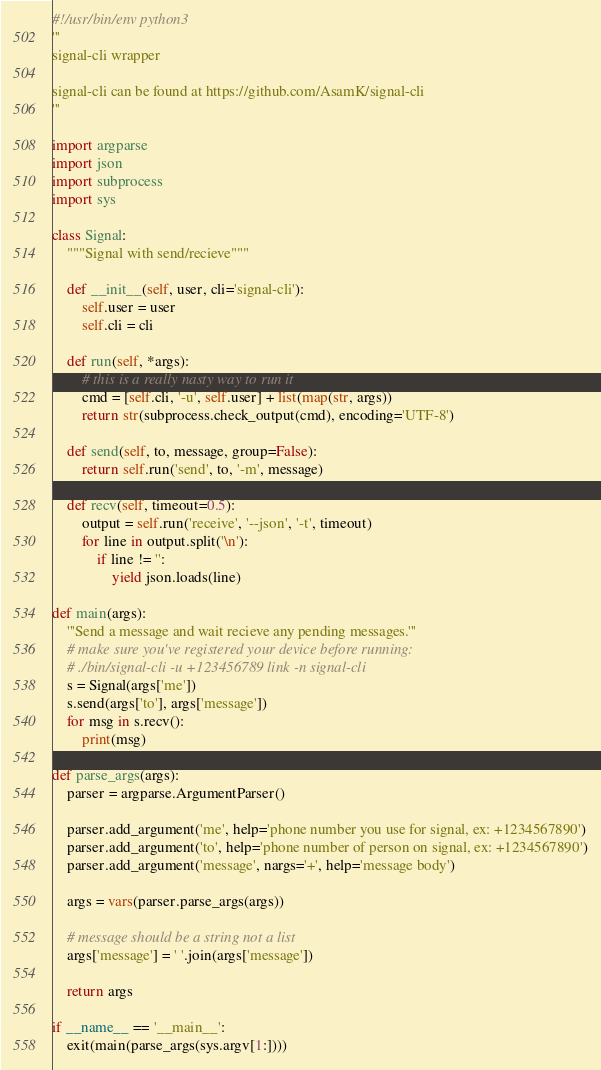Convert code to text. <code><loc_0><loc_0><loc_500><loc_500><_Python_>#!/usr/bin/env python3
'''
signal-cli wrapper

signal-cli can be found at https://github.com/AsamK/signal-cli
'''

import argparse
import json
import subprocess
import sys

class Signal:
    """Signal with send/recieve"""

    def __init__(self, user, cli='signal-cli'):
        self.user = user
        self.cli = cli

    def run(self, *args):
        # this is a really nasty way to run it
        cmd = [self.cli, '-u', self.user] + list(map(str, args))
        return str(subprocess.check_output(cmd), encoding='UTF-8')

    def send(self, to, message, group=False):
        return self.run('send', to, '-m', message)

    def recv(self, timeout=0.5):
        output = self.run('receive', '--json', '-t', timeout)
        for line in output.split('\n'):
            if line != '':
                yield json.loads(line)

def main(args):
    '''Send a message and wait recieve any pending messages.'''
    # make sure you've registered your device before running:
    # ./bin/signal-cli -u +123456789 link -n signal-cli
    s = Signal(args['me'])
    s.send(args['to'], args['message'])
    for msg in s.recv():
        print(msg)

def parse_args(args):
    parser = argparse.ArgumentParser()

    parser.add_argument('me', help='phone number you use for signal, ex: +1234567890')
    parser.add_argument('to', help='phone number of person on signal, ex: +1234567890')
    parser.add_argument('message', nargs='+', help='message body')

    args = vars(parser.parse_args(args))

    # message should be a string not a list
    args['message'] = ' '.join(args['message'])

    return args

if __name__ == '__main__':
    exit(main(parse_args(sys.argv[1:])))

</code> 